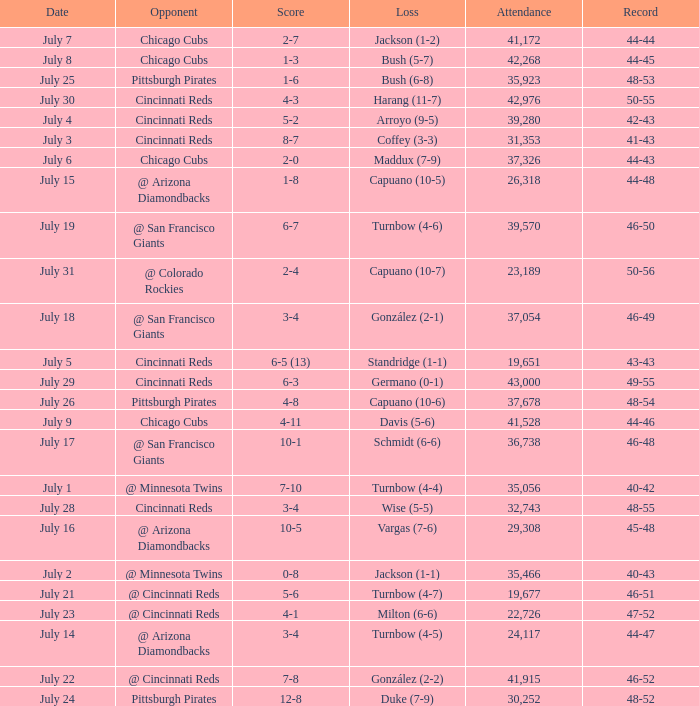What was the record at the game that had a score of 7-10? 40-42. 